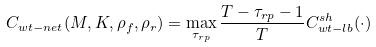Convert formula to latex. <formula><loc_0><loc_0><loc_500><loc_500>C _ { w t - n e t } ( M , K , \rho _ { f } , \rho _ { r } ) = \max _ { \tau _ { r p } } \frac { T - \tau _ { r p } - 1 } { T } C _ { w t - l b } ^ { s h } ( \cdot )</formula> 